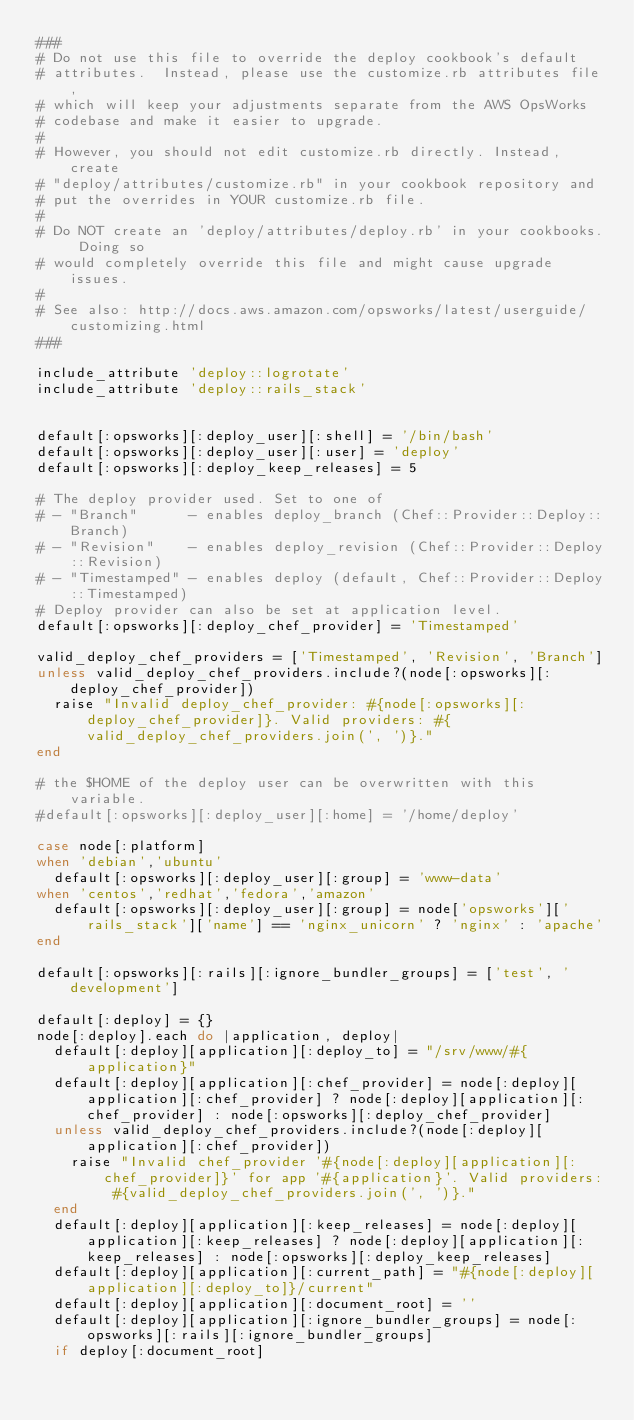Convert code to text. <code><loc_0><loc_0><loc_500><loc_500><_Ruby_>###
# Do not use this file to override the deploy cookbook's default
# attributes.  Instead, please use the customize.rb attributes file,
# which will keep your adjustments separate from the AWS OpsWorks
# codebase and make it easier to upgrade.
#
# However, you should not edit customize.rb directly. Instead, create
# "deploy/attributes/customize.rb" in your cookbook repository and
# put the overrides in YOUR customize.rb file.
#
# Do NOT create an 'deploy/attributes/deploy.rb' in your cookbooks. Doing so
# would completely override this file and might cause upgrade issues.
#
# See also: http://docs.aws.amazon.com/opsworks/latest/userguide/customizing.html
###

include_attribute 'deploy::logrotate'
include_attribute 'deploy::rails_stack'


default[:opsworks][:deploy_user][:shell] = '/bin/bash'
default[:opsworks][:deploy_user][:user] = 'deploy'
default[:opsworks][:deploy_keep_releases] = 5

# The deploy provider used. Set to one of
# - "Branch"      - enables deploy_branch (Chef::Provider::Deploy::Branch)
# - "Revision"    - enables deploy_revision (Chef::Provider::Deploy::Revision)
# - "Timestamped" - enables deploy (default, Chef::Provider::Deploy::Timestamped)
# Deploy provider can also be set at application level.
default[:opsworks][:deploy_chef_provider] = 'Timestamped'

valid_deploy_chef_providers = ['Timestamped', 'Revision', 'Branch']
unless valid_deploy_chef_providers.include?(node[:opsworks][:deploy_chef_provider])
  raise "Invalid deploy_chef_provider: #{node[:opsworks][:deploy_chef_provider]}. Valid providers: #{valid_deploy_chef_providers.join(', ')}."
end

# the $HOME of the deploy user can be overwritten with this variable.
#default[:opsworks][:deploy_user][:home] = '/home/deploy'

case node[:platform]
when 'debian','ubuntu'
  default[:opsworks][:deploy_user][:group] = 'www-data'
when 'centos','redhat','fedora','amazon'
  default[:opsworks][:deploy_user][:group] = node['opsworks']['rails_stack']['name'] == 'nginx_unicorn' ? 'nginx' : 'apache'
end

default[:opsworks][:rails][:ignore_bundler_groups] = ['test', 'development']

default[:deploy] = {}
node[:deploy].each do |application, deploy|
  default[:deploy][application][:deploy_to] = "/srv/www/#{application}"
  default[:deploy][application][:chef_provider] = node[:deploy][application][:chef_provider] ? node[:deploy][application][:chef_provider] : node[:opsworks][:deploy_chef_provider]
  unless valid_deploy_chef_providers.include?(node[:deploy][application][:chef_provider])
    raise "Invalid chef_provider '#{node[:deploy][application][:chef_provider]}' for app '#{application}'. Valid providers: #{valid_deploy_chef_providers.join(', ')}."
  end
  default[:deploy][application][:keep_releases] = node[:deploy][application][:keep_releases] ? node[:deploy][application][:keep_releases] : node[:opsworks][:deploy_keep_releases]
  default[:deploy][application][:current_path] = "#{node[:deploy][application][:deploy_to]}/current"
  default[:deploy][application][:document_root] = ''
  default[:deploy][application][:ignore_bundler_groups] = node[:opsworks][:rails][:ignore_bundler_groups]
  if deploy[:document_root]</code> 